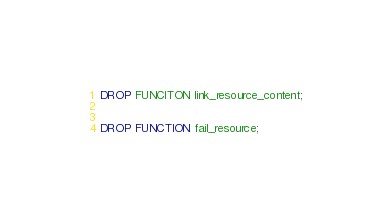<code> <loc_0><loc_0><loc_500><loc_500><_SQL_>DROP FUNCITON link_resource_content;


DROP FUNCTION fail_resource;

</code> 